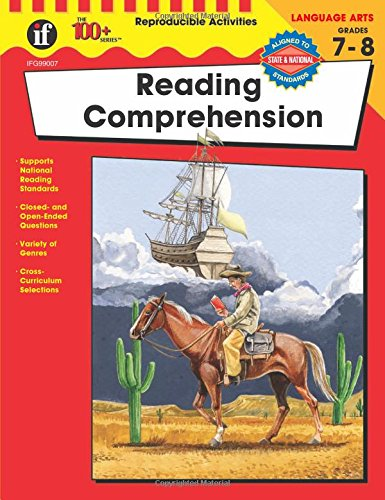Could you explain what the cover image suggests about the book's content? The cover features a cowboy on a horse and a large sailing ship, likely symbolizing adventure and exploration. It suggests the book uses engaging historical and adventurous contexts to make reading exercises more appealing and contextual. 